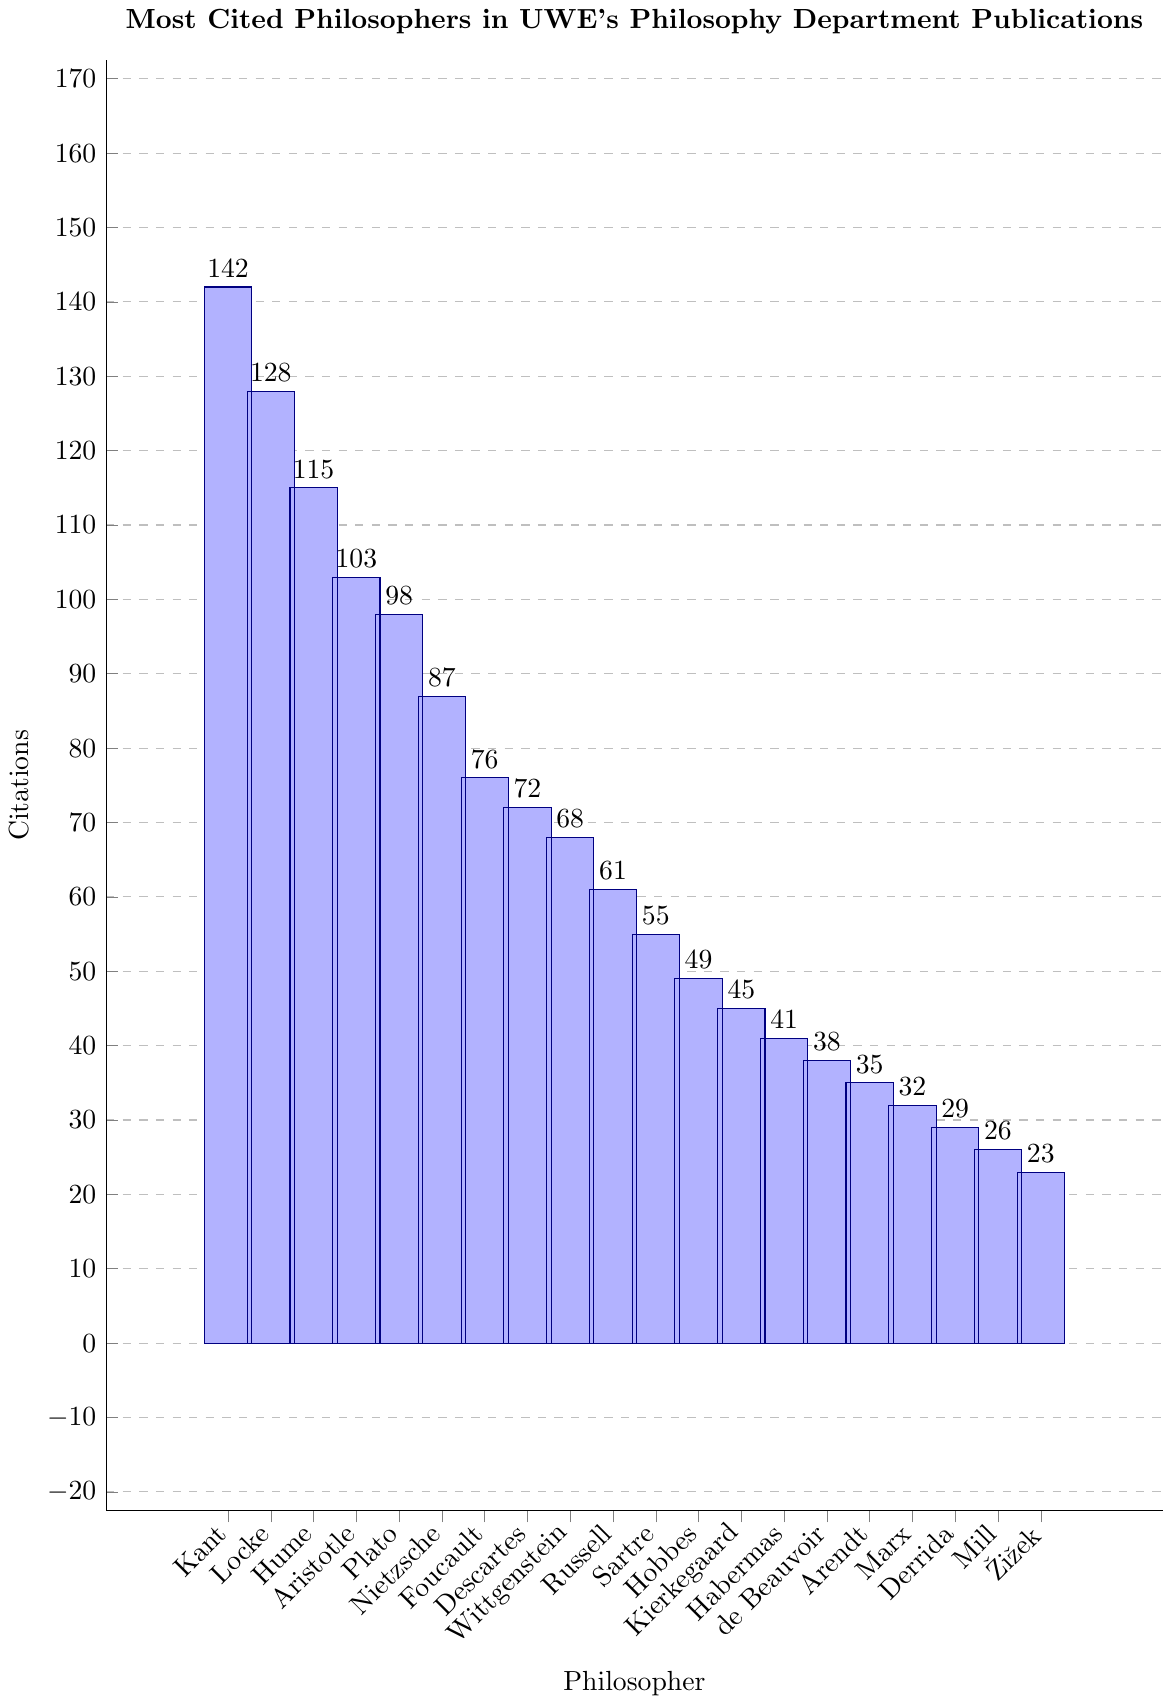What's the most cited philosopher in UWE's philosophy department publications? The bar chart indicates the citations per philosopher. The bar for Immanuel Kant is the highest.
Answer: Immanuel Kant How many more citations does Immanuel Kant have compared to John Locke? Immanuel Kant has 142 citations, and John Locke has 128 citations. The difference is 142 - 128 = 14.
Answer: 14 Which philosopher has the least citations, and how many citations do they have? The shortest bar represents Slavoj Žižek, which indicates he has the least citations. According to the chart, he has 23 citations.
Answer: Slavoj Žižek, 23 What is the total number of citations for the top three most cited philosophers? The citations are 142 (Immanuel Kant), 128 (John Locke), and 115 (David Hume). The total is 142 + 128 + 115 = 385.
Answer: 385 Is Plato cited more often than Aristotle? According to the bar chart, Aristotle has 103 citations, and Plato has 98 citations. Aristotle is cited more often.
Answer: No What's the average number of citations for Michel Foucault, René Descartes, and Ludwig Wittgenstein? The citations are 76 (Michel Foucault), 72 (René Descartes), and 68 (Ludwig Wittgenstein). Sum them: 76 + 72 + 68 = 216. The average is 216 / 3 = 72.
Answer: 72 Are any philosophers cited exactly 50 times? By examining the chart, no bar corresponds exactly to 50 citations.
Answer: No What is the difference in citations between Friedrich Nietzsche and Jürgen Habermas? Friedrich Nietzsche has 87 citations, while Jürgen Habermas has 41. The difference is 87 - 41 = 46.
Answer: 46 Who are the philosophers cited between 30 and 40 times? By examining the chart, Simone de Beauvoir (38), Hannah Arendt (35), and Karl Marx (32) fall within this range.
Answer: Simone de Beauvoir, Hannah Arendt, Karl Marx Which philosopher is ranked 10th in terms of citations? By ordering the philosophers by their citations, Bertrand Russell, with 61 citations, is the 10th most cited.
Answer: Bertrand Russell 